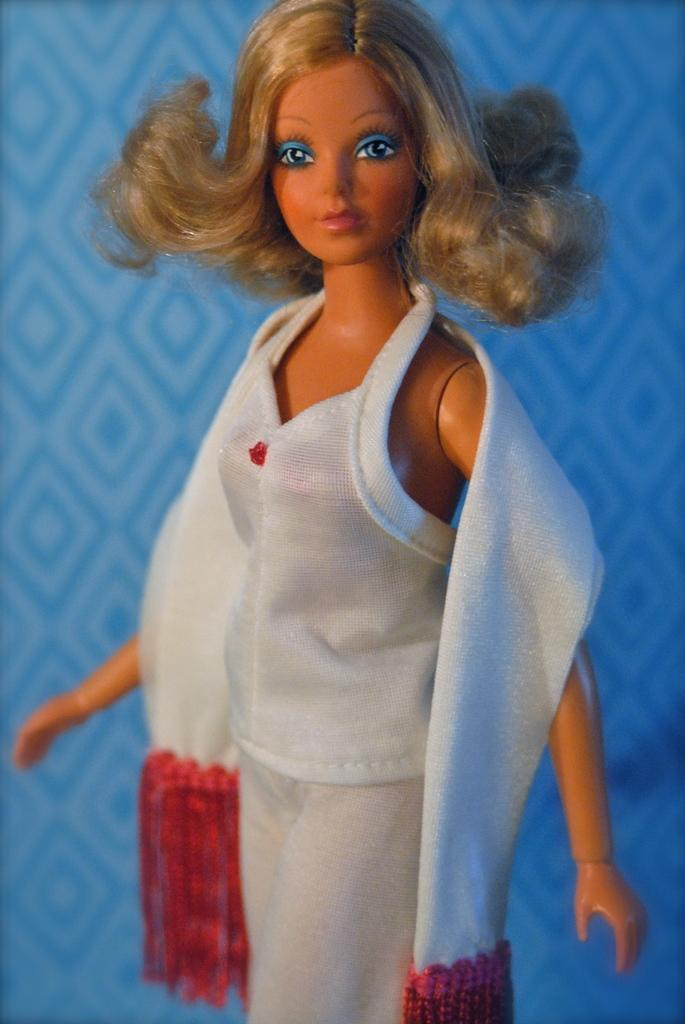What is the main subject in the front of the image? There is a doll in the front of the image. What type of material is visible in the image? There is cloth visible in the image. What color is the background of the image? The background of the image is blue. What type of dish is the cook preparing in the image? There is no cook or dish preparation present in the image; it features a doll and cloth with a blue background. 